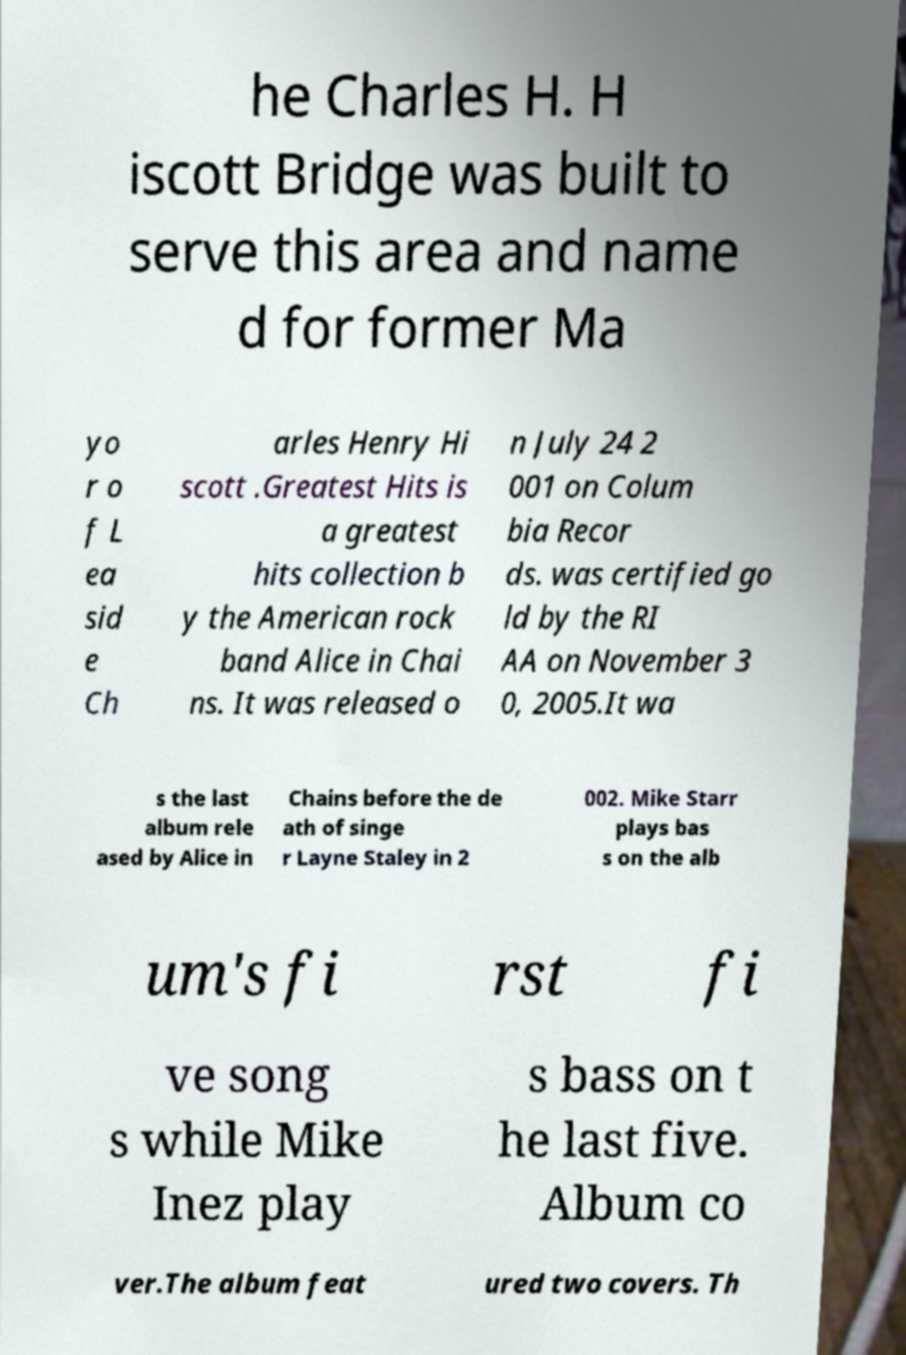I need the written content from this picture converted into text. Can you do that? he Charles H. H iscott Bridge was built to serve this area and name d for former Ma yo r o f L ea sid e Ch arles Henry Hi scott .Greatest Hits is a greatest hits collection b y the American rock band Alice in Chai ns. It was released o n July 24 2 001 on Colum bia Recor ds. was certified go ld by the RI AA on November 3 0, 2005.It wa s the last album rele ased by Alice in Chains before the de ath of singe r Layne Staley in 2 002. Mike Starr plays bas s on the alb um's fi rst fi ve song s while Mike Inez play s bass on t he last five. Album co ver.The album feat ured two covers. Th 